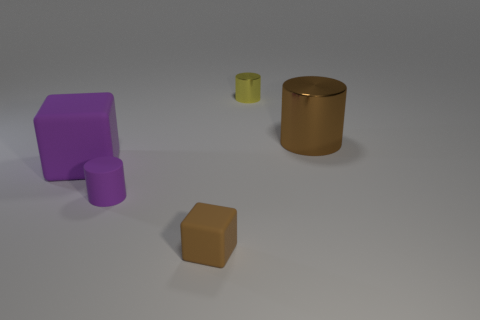Subtract all shiny cylinders. How many cylinders are left? 1 Subtract all purple cylinders. How many cylinders are left? 2 Subtract 2 cylinders. How many cylinders are left? 1 Subtract all cylinders. How many objects are left? 2 Subtract all cyan blocks. Subtract all gray spheres. How many blocks are left? 2 Subtract all brown balls. How many yellow cylinders are left? 1 Add 3 tiny purple things. How many objects exist? 8 Subtract 1 purple cylinders. How many objects are left? 4 Subtract all balls. Subtract all big purple things. How many objects are left? 4 Add 5 small brown rubber blocks. How many small brown rubber blocks are left? 6 